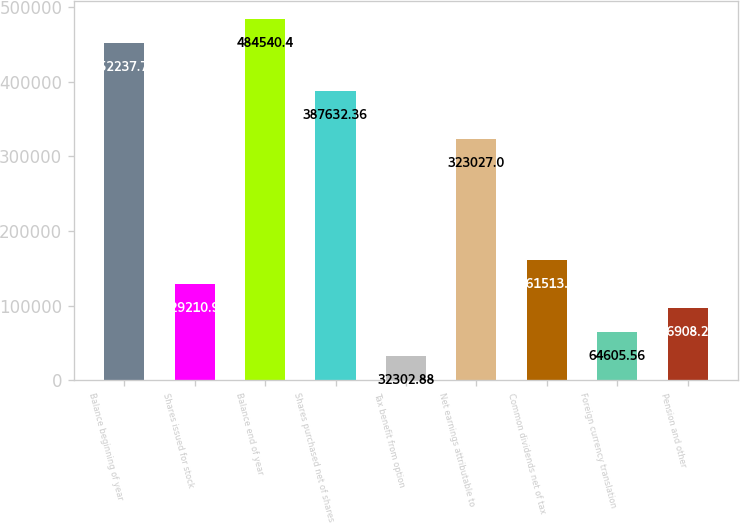Convert chart. <chart><loc_0><loc_0><loc_500><loc_500><bar_chart><fcel>Balance beginning of year<fcel>Shares issued for stock<fcel>Balance end of year<fcel>Shares purchased net of shares<fcel>Tax benefit from option<fcel>Net earnings attributable to<fcel>Common dividends net of tax<fcel>Foreign currency translation<fcel>Pension and other<nl><fcel>452238<fcel>129211<fcel>484540<fcel>387632<fcel>32302.9<fcel>323027<fcel>161514<fcel>64605.6<fcel>96908.2<nl></chart> 